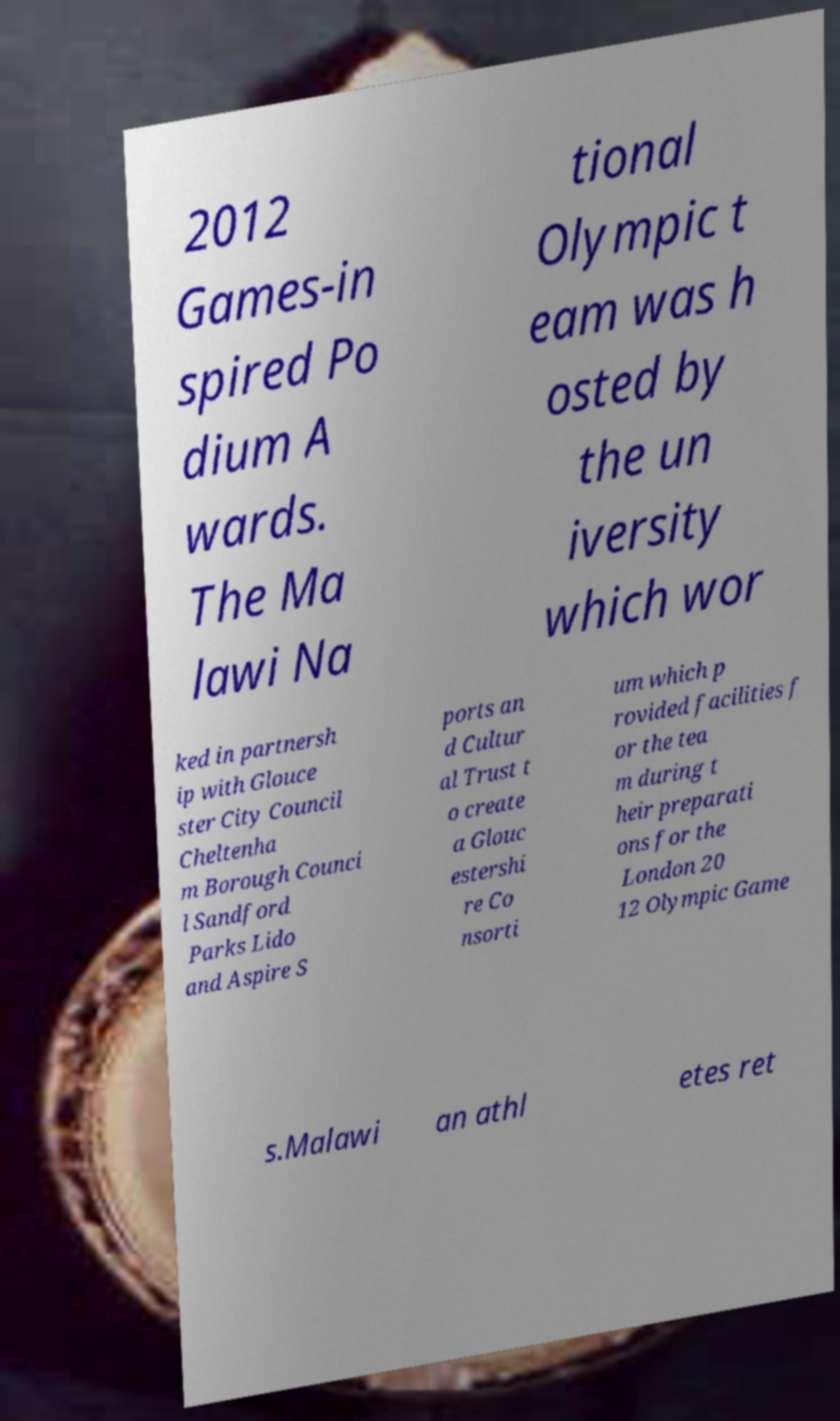Can you read and provide the text displayed in the image?This photo seems to have some interesting text. Can you extract and type it out for me? 2012 Games-in spired Po dium A wards. The Ma lawi Na tional Olympic t eam was h osted by the un iversity which wor ked in partnersh ip with Glouce ster City Council Cheltenha m Borough Counci l Sandford Parks Lido and Aspire S ports an d Cultur al Trust t o create a Glouc estershi re Co nsorti um which p rovided facilities f or the tea m during t heir preparati ons for the London 20 12 Olympic Game s.Malawi an athl etes ret 